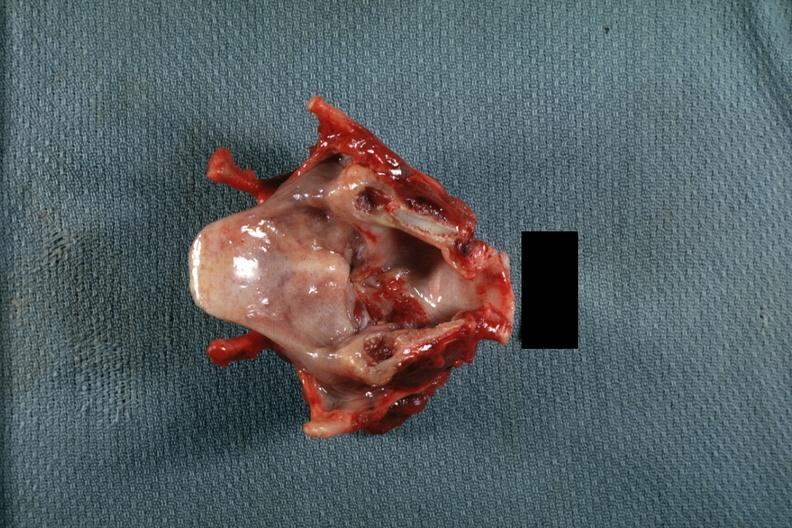s carcinoma present?
Answer the question using a single word or phrase. Yes 